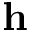Convert formula to latex. <formula><loc_0><loc_0><loc_500><loc_500>h</formula> 